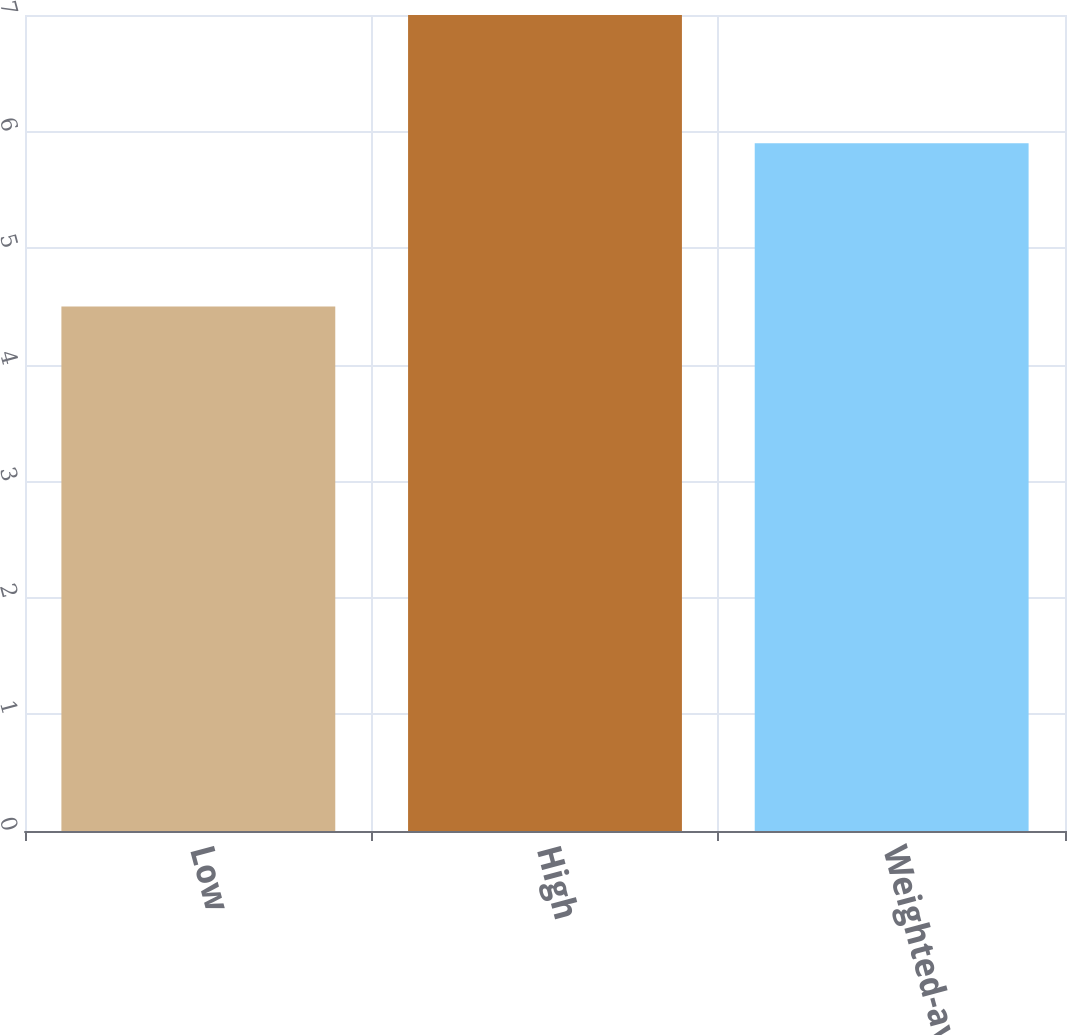Convert chart to OTSL. <chart><loc_0><loc_0><loc_500><loc_500><bar_chart><fcel>Low<fcel>High<fcel>Weighted-average<nl><fcel>4.5<fcel>7<fcel>5.9<nl></chart> 